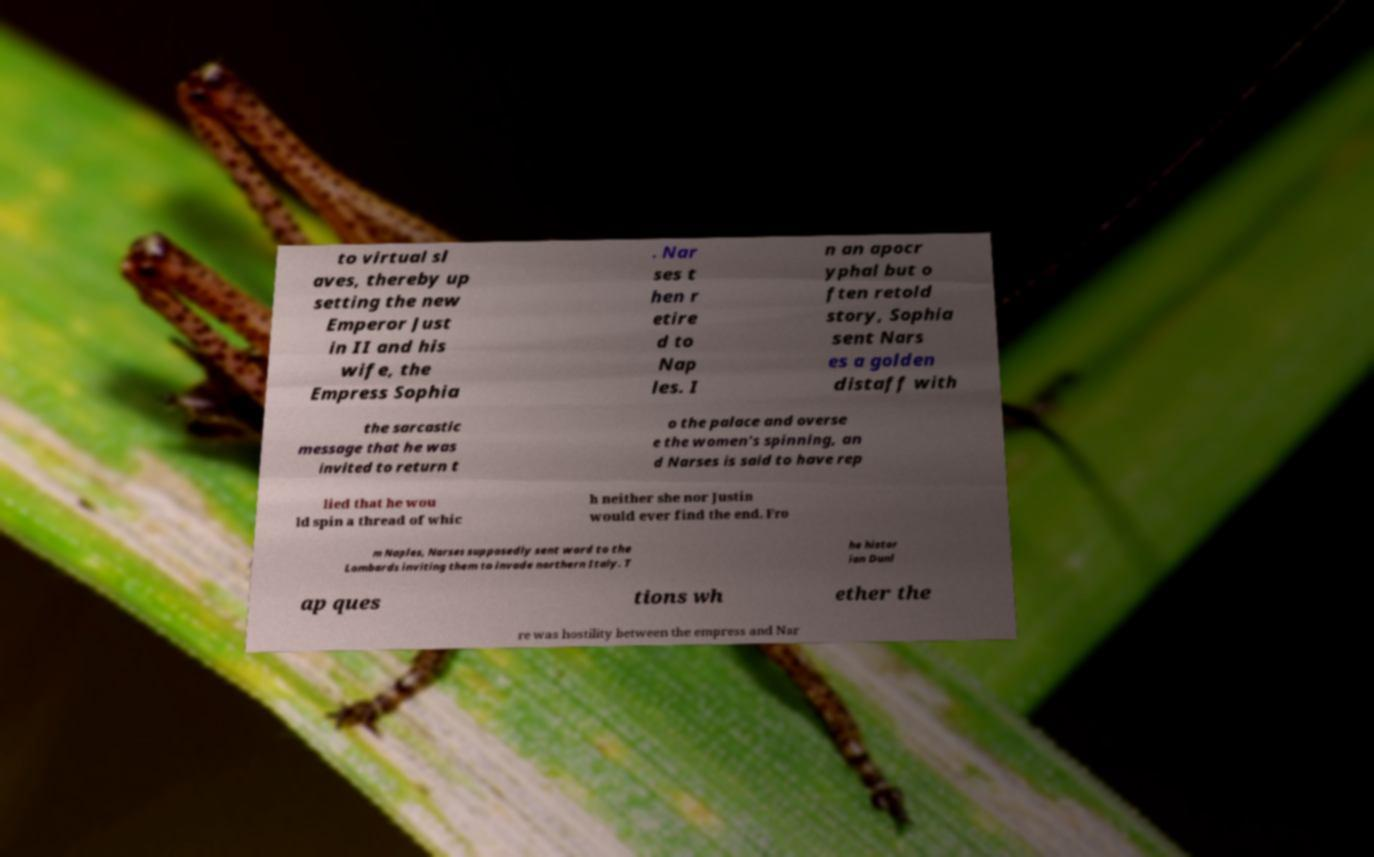Can you read and provide the text displayed in the image?This photo seems to have some interesting text. Can you extract and type it out for me? to virtual sl aves, thereby up setting the new Emperor Just in II and his wife, the Empress Sophia . Nar ses t hen r etire d to Nap les. I n an apocr yphal but o ften retold story, Sophia sent Nars es a golden distaff with the sarcastic message that he was invited to return t o the palace and overse e the women's spinning, an d Narses is said to have rep lied that he wou ld spin a thread of whic h neither she nor Justin would ever find the end. Fro m Naples, Narses supposedly sent word to the Lombards inviting them to invade northern Italy. T he histor ian Dunl ap ques tions wh ether the re was hostility between the empress and Nar 